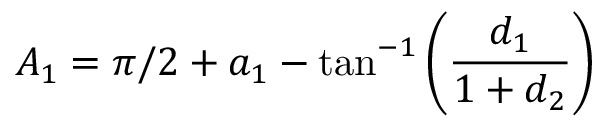<formula> <loc_0><loc_0><loc_500><loc_500>{ A _ { 1 } } = \pi / 2 + { a _ { 1 } } - \tan ^ { - 1 } \left ( \frac { d _ { 1 } } { 1 + d _ { 2 } } \right )</formula> 